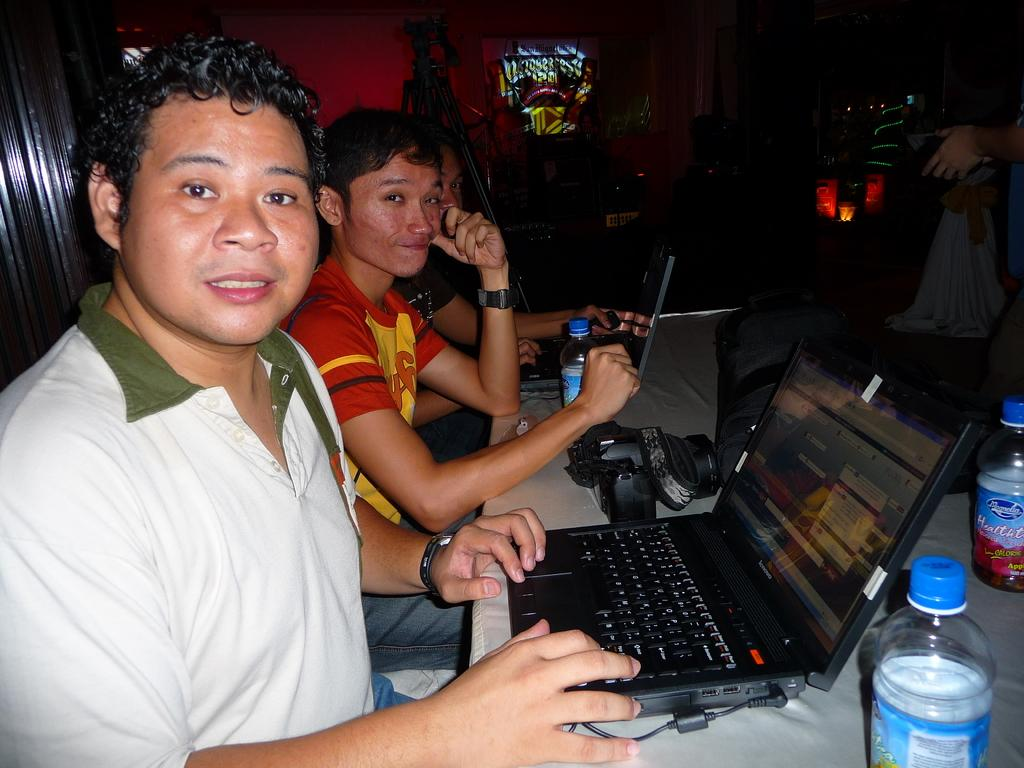How many people are sitting in the image? There are three people sitting in the image. What objects can be seen on the table in the image? On the table, there is a camera, a water bottle, and a laptop. What type of wire is being used to polish the horses in the image? There are no horses or wire present in the image. 